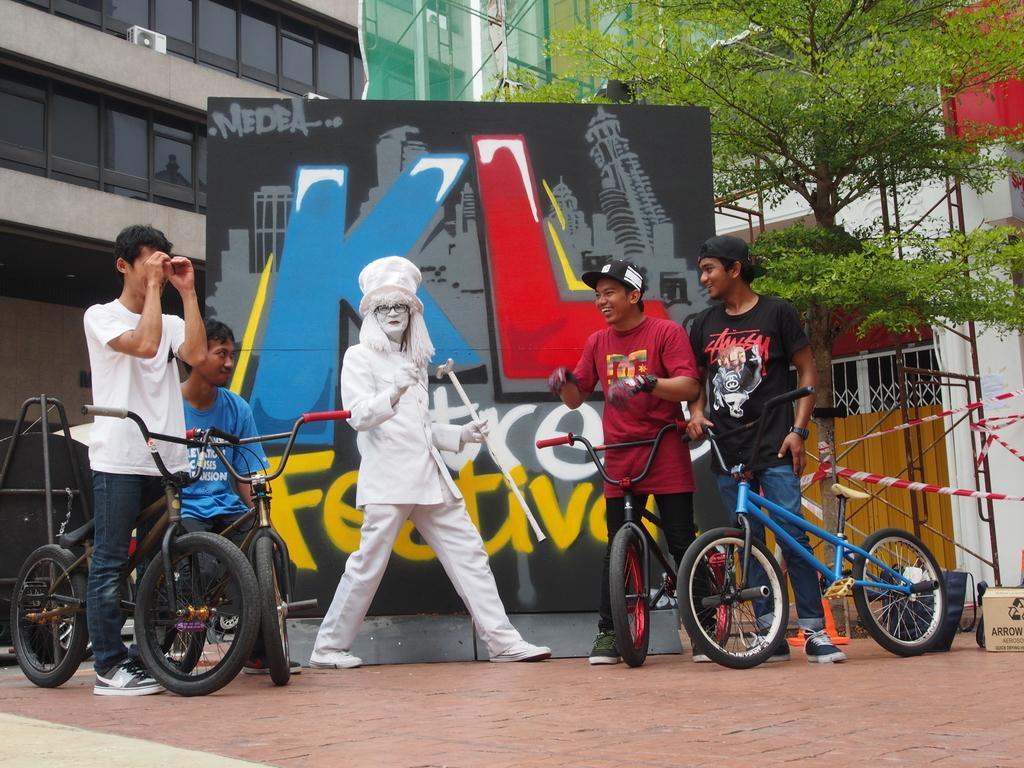Can you describe this image briefly? In this picture few guys are on a bicycle and a lady is white coated herself in front of a poster named KL. 